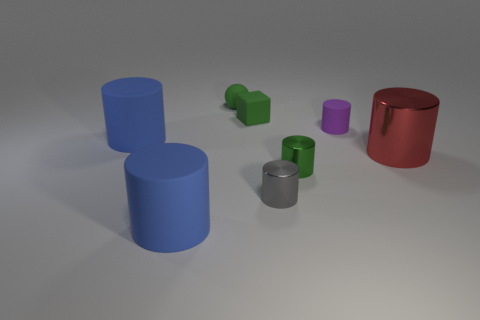Subtract all big metallic cylinders. How many cylinders are left? 5 Add 2 metal cylinders. How many objects exist? 10 Subtract 1 balls. How many balls are left? 0 Subtract all purple cylinders. How many cylinders are left? 5 Subtract all cubes. How many objects are left? 7 Subtract all yellow balls. How many blue cylinders are left? 2 Subtract all green spheres. Subtract all red objects. How many objects are left? 6 Add 5 gray shiny things. How many gray shiny things are left? 6 Add 5 balls. How many balls exist? 6 Subtract 2 blue cylinders. How many objects are left? 6 